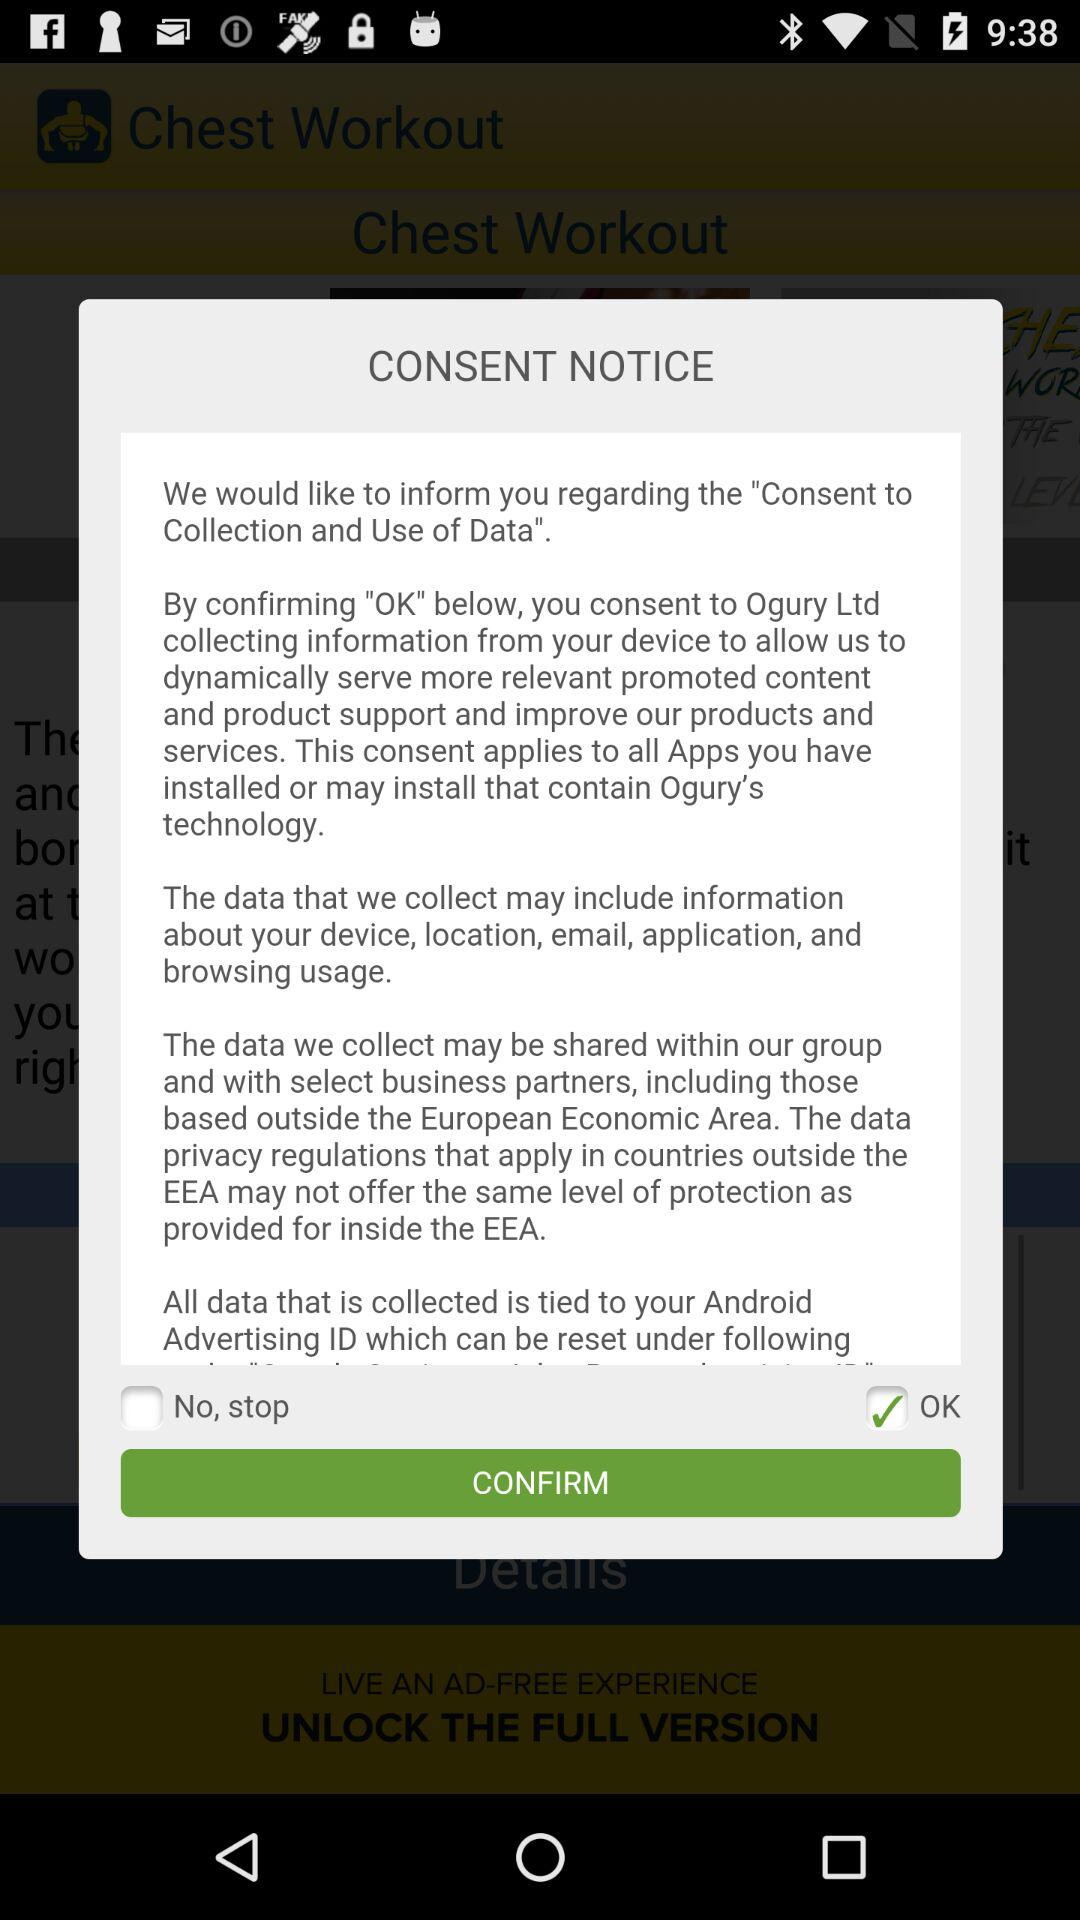What is the current status of the "No, stop" setting? The current status is "off". 